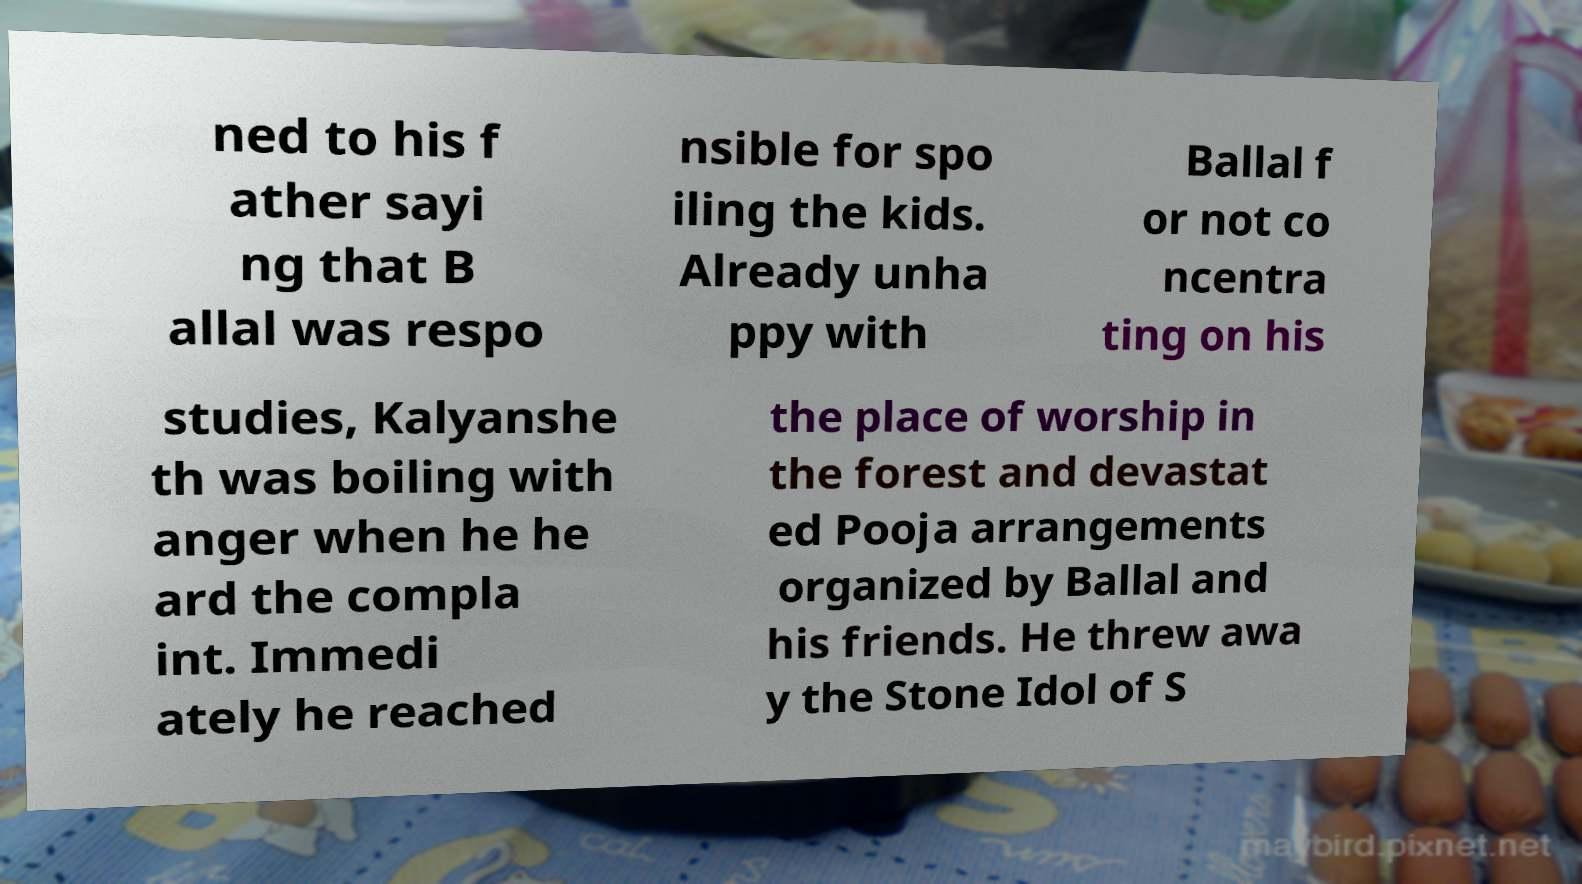Could you assist in decoding the text presented in this image and type it out clearly? ned to his f ather sayi ng that B allal was respo nsible for spo iling the kids. Already unha ppy with Ballal f or not co ncentra ting on his studies, Kalyanshe th was boiling with anger when he he ard the compla int. Immedi ately he reached the place of worship in the forest and devastat ed Pooja arrangements organized by Ballal and his friends. He threw awa y the Stone Idol of S 